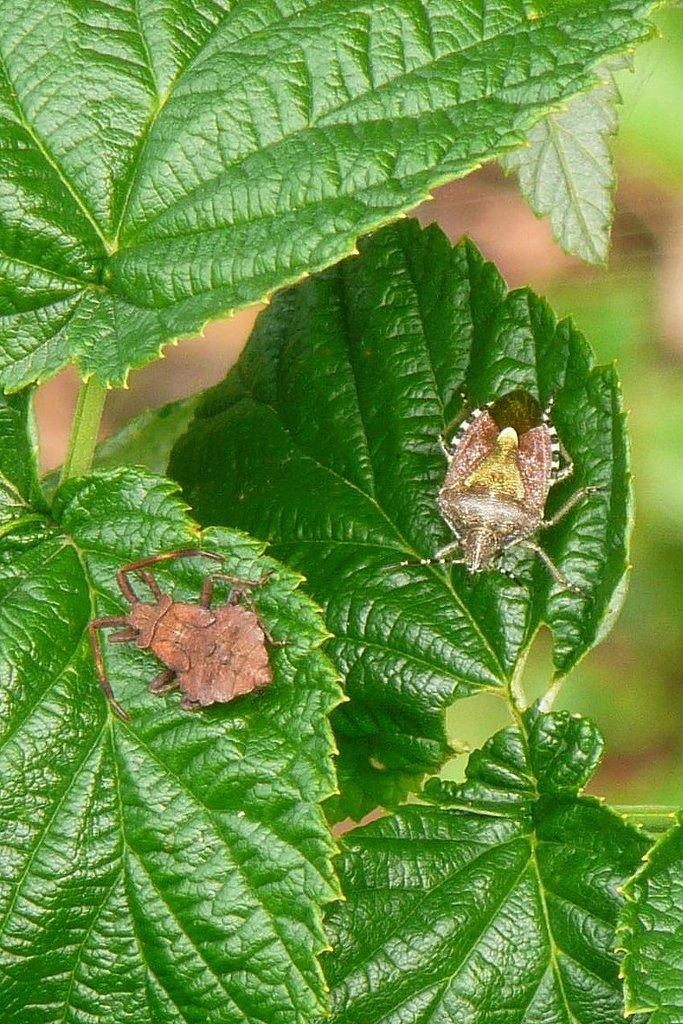How many insects are present in the image? There are two insects in the image. Where are the insects located? The insects are on leaves. Can you describe the background of the image? The background of the image is blurred. What type of shoe can be seen in the image? There is no shoe present in the image; it features two insects on leaves with a blurred background. 